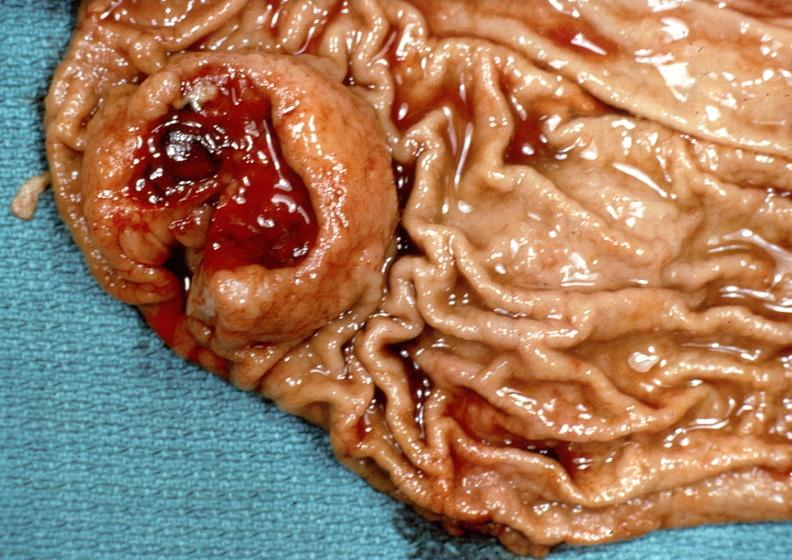s gastrointestinal present?
Answer the question using a single word or phrase. Yes 